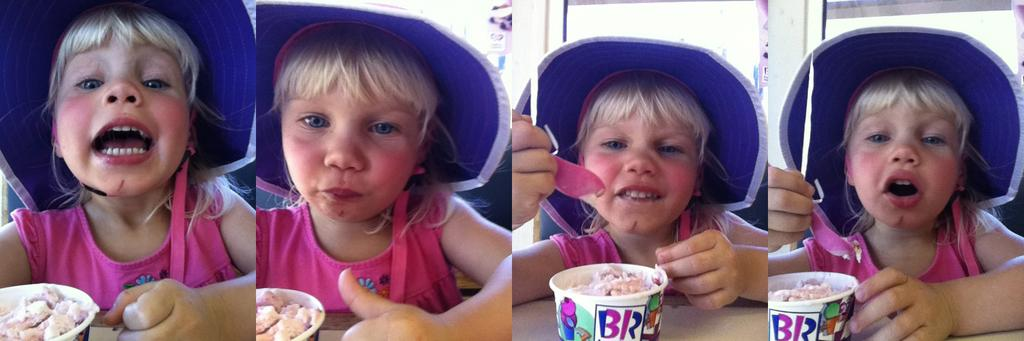What type of picture is in the image? There is a collage picture in the image. What is the subject of the collage picture? The collage picture depicts a kid. What is the kid doing in the image? The kid is eating ice cream in the image. What type of sock is the kid wearing in the image? There is no sock visible in the image, as the focus is on the collage picture and the kid eating ice cream. 